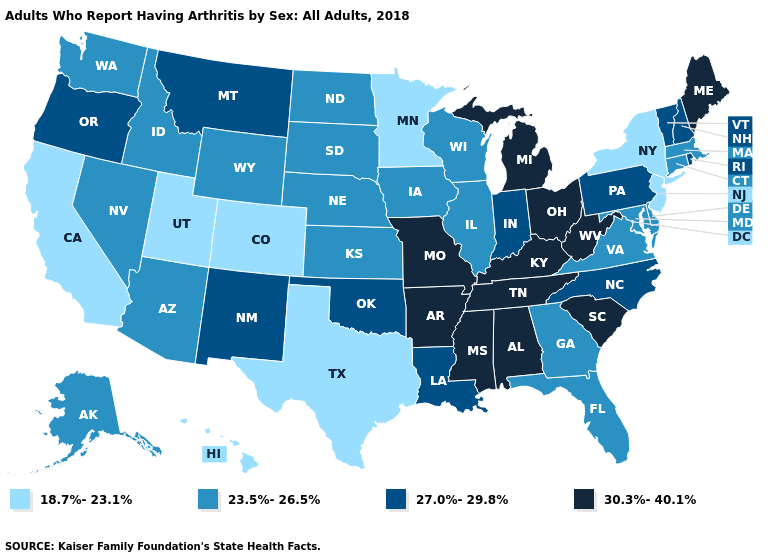Does the first symbol in the legend represent the smallest category?
Answer briefly. Yes. Name the states that have a value in the range 18.7%-23.1%?
Keep it brief. California, Colorado, Hawaii, Minnesota, New Jersey, New York, Texas, Utah. Which states have the lowest value in the South?
Concise answer only. Texas. Does New Hampshire have a higher value than Rhode Island?
Quick response, please. No. Name the states that have a value in the range 27.0%-29.8%?
Quick response, please. Indiana, Louisiana, Montana, New Hampshire, New Mexico, North Carolina, Oklahoma, Oregon, Pennsylvania, Rhode Island, Vermont. Which states hav the highest value in the Northeast?
Write a very short answer. Maine. Which states have the lowest value in the USA?
Write a very short answer. California, Colorado, Hawaii, Minnesota, New Jersey, New York, Texas, Utah. Name the states that have a value in the range 30.3%-40.1%?
Keep it brief. Alabama, Arkansas, Kentucky, Maine, Michigan, Mississippi, Missouri, Ohio, South Carolina, Tennessee, West Virginia. Name the states that have a value in the range 27.0%-29.8%?
Concise answer only. Indiana, Louisiana, Montana, New Hampshire, New Mexico, North Carolina, Oklahoma, Oregon, Pennsylvania, Rhode Island, Vermont. Name the states that have a value in the range 30.3%-40.1%?
Keep it brief. Alabama, Arkansas, Kentucky, Maine, Michigan, Mississippi, Missouri, Ohio, South Carolina, Tennessee, West Virginia. What is the value of Arkansas?
Keep it brief. 30.3%-40.1%. Does the map have missing data?
Concise answer only. No. What is the highest value in the USA?
Give a very brief answer. 30.3%-40.1%. Name the states that have a value in the range 30.3%-40.1%?
Write a very short answer. Alabama, Arkansas, Kentucky, Maine, Michigan, Mississippi, Missouri, Ohio, South Carolina, Tennessee, West Virginia. Does Wisconsin have the highest value in the MidWest?
Write a very short answer. No. 